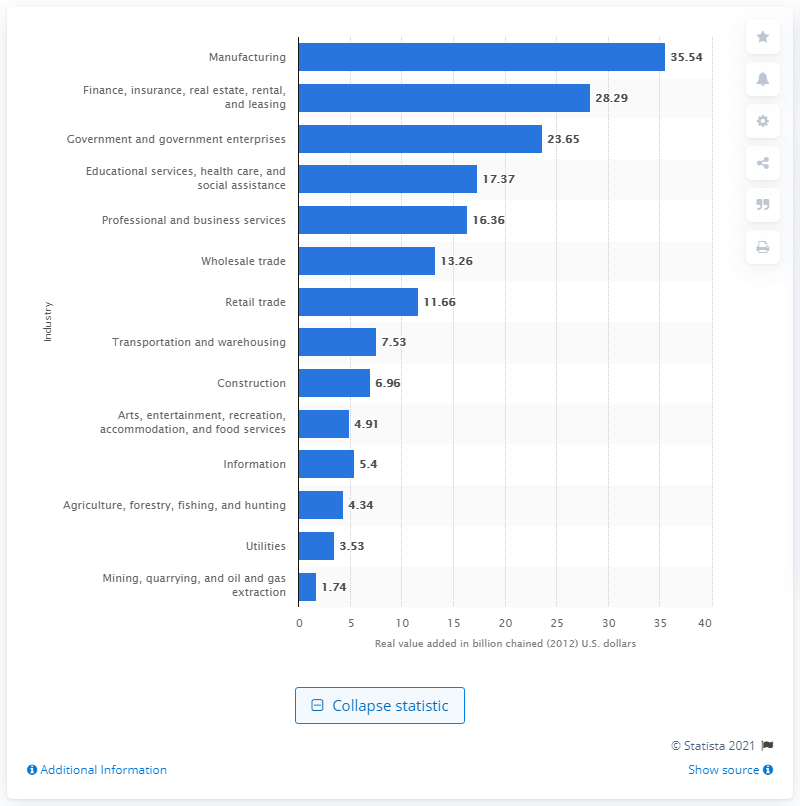How much value did the manufacturing industry add to Kentucky's GDP in 2020?
 35.54 